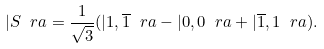<formula> <loc_0><loc_0><loc_500><loc_500>| S \ r a = \frac { 1 } { \sqrt { 3 } } ( | 1 , \overline { 1 } \ r a - | 0 , 0 \ r a + | \overline { 1 } , 1 \ r a ) .</formula> 